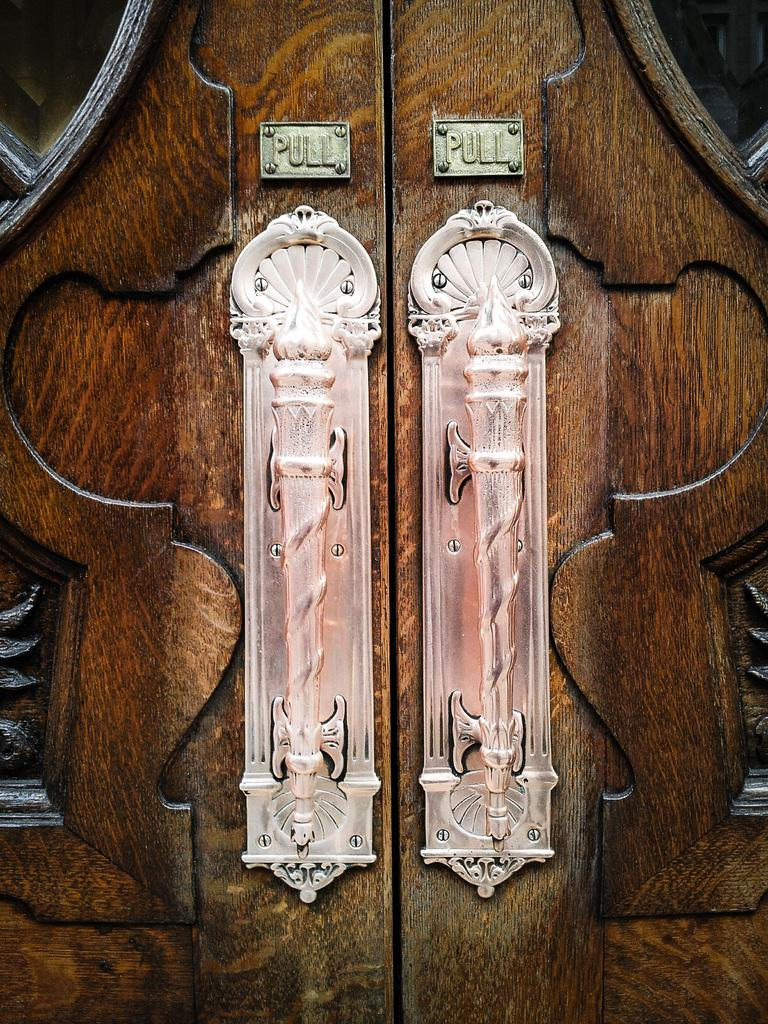What color are the doors in the image? The doors in the image are brown-colored. How many handles are on each door? Each door has two handles. What is the structure of each door? Each door has two boards. What instruction is provided on the boards? The word "pull" is written on the boards. What type of summer activity is happening on the island in the image? There is no island or summer activity present in the image; it features brown-colored doors with handles and boards. What color are the socks worn by the person in the image? There is no person or socks visible in the image; it only shows brown-colored doors with handles and boards. 